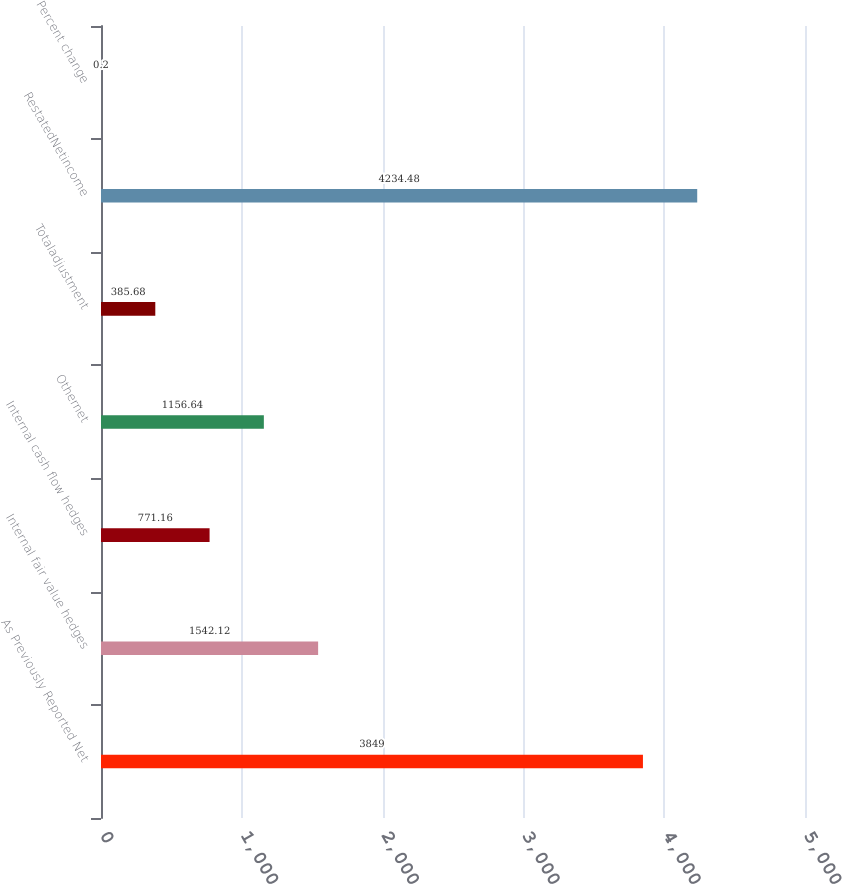Convert chart. <chart><loc_0><loc_0><loc_500><loc_500><bar_chart><fcel>As Previously Reported Net<fcel>Internal fair value hedges<fcel>Internal cash flow hedges<fcel>Othernet<fcel>Totaladjustment<fcel>RestatedNetincome<fcel>Percent change<nl><fcel>3849<fcel>1542.12<fcel>771.16<fcel>1156.64<fcel>385.68<fcel>4234.48<fcel>0.2<nl></chart> 